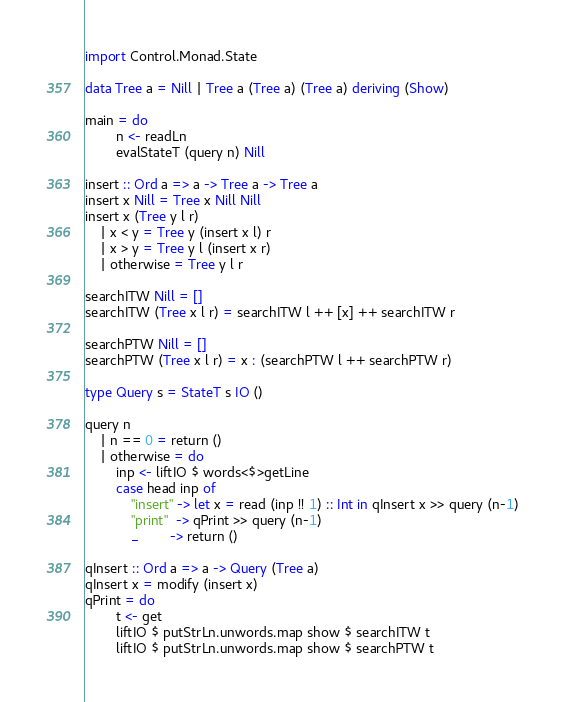Convert code to text. <code><loc_0><loc_0><loc_500><loc_500><_Haskell_>import Control.Monad.State

data Tree a = Nill | Tree a (Tree a) (Tree a) deriving (Show)

main = do
        n <- readLn
        evalStateT (query n) Nill

insert :: Ord a => a -> Tree a -> Tree a
insert x Nill = Tree x Nill Nill
insert x (Tree y l r)
    | x < y = Tree y (insert x l) r
    | x > y = Tree y l (insert x r)
    | otherwise = Tree y l r

searchITW Nill = []
searchITW (Tree x l r) = searchITW l ++ [x] ++ searchITW r

searchPTW Nill = []
searchPTW (Tree x l r) = x : (searchPTW l ++ searchPTW r)

type Query s = StateT s IO ()

query n
    | n == 0 = return ()
    | otherwise = do
        inp <- liftIO $ words<$>getLine
        case head inp of
            "insert" -> let x = read (inp !! 1) :: Int in qInsert x >> query (n-1)
            "print"  -> qPrint >> query (n-1)
            _        -> return ()

qInsert :: Ord a => a -> Query (Tree a)
qInsert x = modify (insert x)
qPrint = do
        t <- get
        liftIO $ putStrLn.unwords.map show $ searchITW t
        liftIO $ putStrLn.unwords.map show $ searchPTW t</code> 